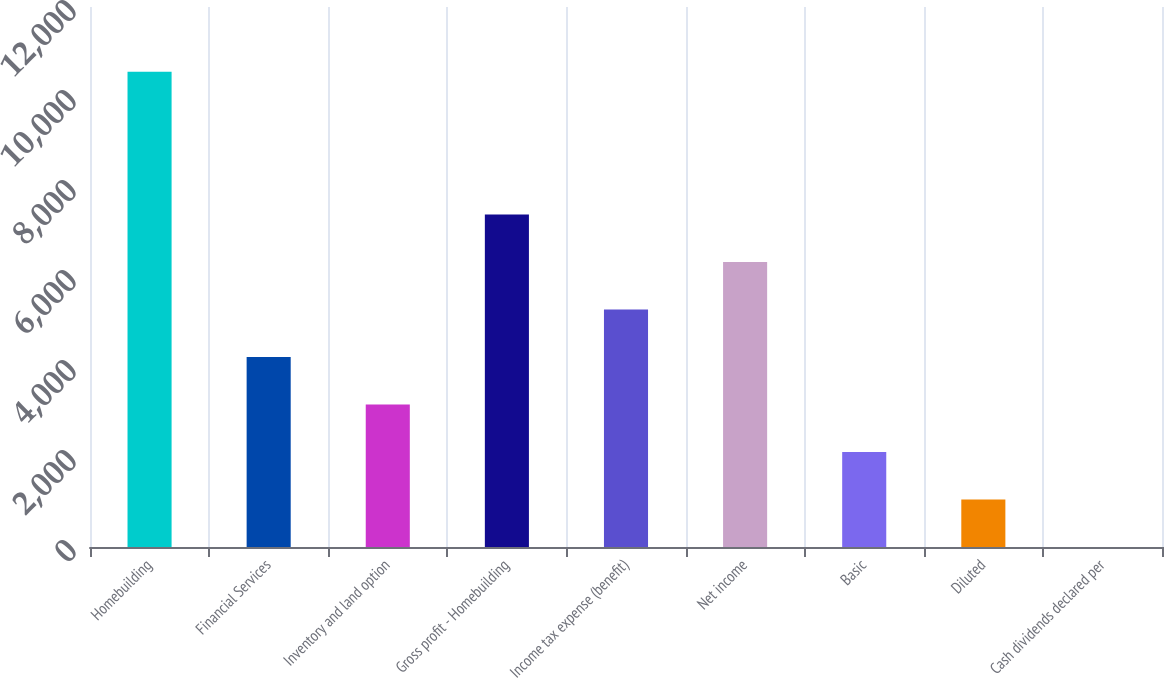Convert chart. <chart><loc_0><loc_0><loc_500><loc_500><bar_chart><fcel>Homebuilding<fcel>Financial Services<fcel>Inventory and land option<fcel>Gross profit - Homebuilding<fcel>Income tax expense (benefit)<fcel>Net income<fcel>Basic<fcel>Diluted<fcel>Cash dividends declared per<nl><fcel>10559<fcel>4223.74<fcel>3167.86<fcel>7391.35<fcel>5279.61<fcel>6335.48<fcel>2111.99<fcel>1056.12<fcel>0.25<nl></chart> 